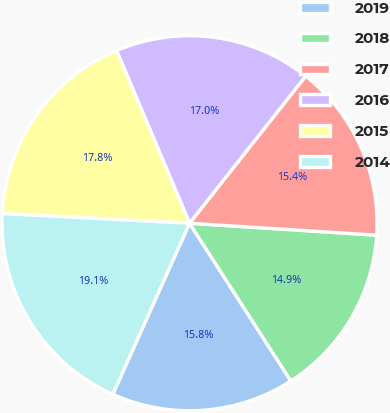<chart> <loc_0><loc_0><loc_500><loc_500><pie_chart><fcel>2019<fcel>2018<fcel>2017<fcel>2016<fcel>2015<fcel>2014<nl><fcel>15.8%<fcel>14.9%<fcel>15.38%<fcel>17.0%<fcel>17.81%<fcel>19.11%<nl></chart> 